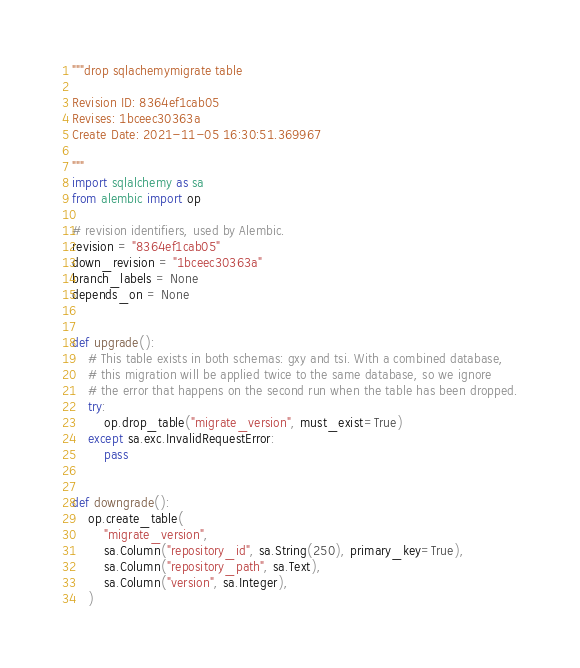Convert code to text. <code><loc_0><loc_0><loc_500><loc_500><_Python_>"""drop sqlachemymigrate table

Revision ID: 8364ef1cab05
Revises: 1bceec30363a
Create Date: 2021-11-05 16:30:51.369967

"""
import sqlalchemy as sa
from alembic import op

# revision identifiers, used by Alembic.
revision = "8364ef1cab05"
down_revision = "1bceec30363a"
branch_labels = None
depends_on = None


def upgrade():
    # This table exists in both schemas: gxy and tsi. With a combined database,
    # this migration will be applied twice to the same database, so we ignore
    # the error that happens on the second run when the table has been dropped.
    try:
        op.drop_table("migrate_version", must_exist=True)
    except sa.exc.InvalidRequestError:
        pass


def downgrade():
    op.create_table(
        "migrate_version",
        sa.Column("repository_id", sa.String(250), primary_key=True),
        sa.Column("repository_path", sa.Text),
        sa.Column("version", sa.Integer),
    )
</code> 